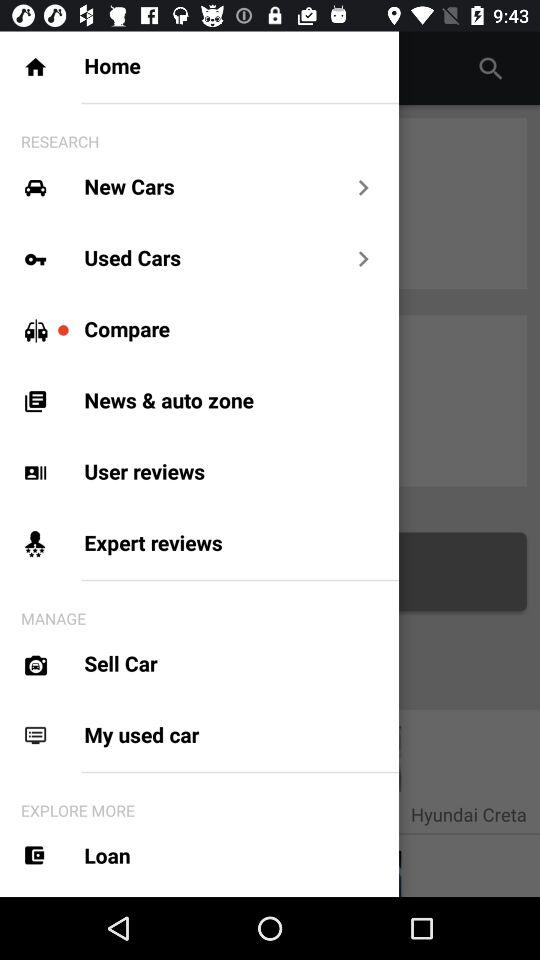How many more items are in the Manage section than the Research section?
Answer the question using a single word or phrase. 2 